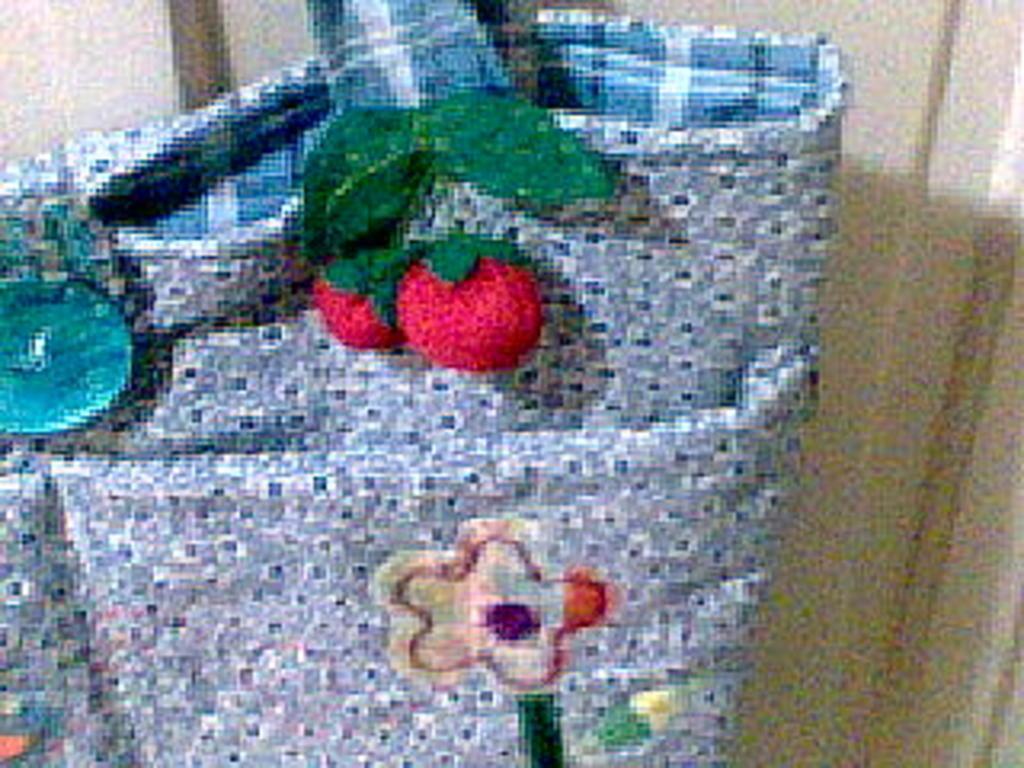How would you summarize this image in a sentence or two? Blue color bag with red color cherries on it. And a flower and a blue color button to it. 